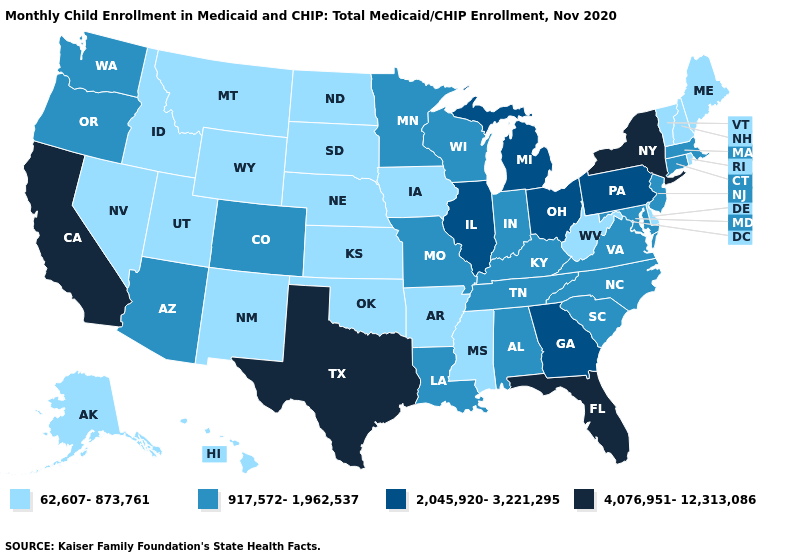Name the states that have a value in the range 62,607-873,761?
Keep it brief. Alaska, Arkansas, Delaware, Hawaii, Idaho, Iowa, Kansas, Maine, Mississippi, Montana, Nebraska, Nevada, New Hampshire, New Mexico, North Dakota, Oklahoma, Rhode Island, South Dakota, Utah, Vermont, West Virginia, Wyoming. What is the value of Idaho?
Give a very brief answer. 62,607-873,761. Which states hav the highest value in the South?
Keep it brief. Florida, Texas. Does the first symbol in the legend represent the smallest category?
Quick response, please. Yes. Does Wisconsin have a higher value than Illinois?
Keep it brief. No. Does the map have missing data?
Be succinct. No. Does the first symbol in the legend represent the smallest category?
Concise answer only. Yes. Does the map have missing data?
Concise answer only. No. Which states hav the highest value in the Northeast?
Keep it brief. New York. Does the first symbol in the legend represent the smallest category?
Write a very short answer. Yes. Does Alaska have a lower value than South Dakota?
Write a very short answer. No. What is the lowest value in the West?
Be succinct. 62,607-873,761. What is the highest value in the USA?
Give a very brief answer. 4,076,951-12,313,086. Name the states that have a value in the range 4,076,951-12,313,086?
Quick response, please. California, Florida, New York, Texas. 